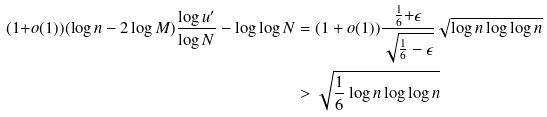Convert formula to latex. <formula><loc_0><loc_0><loc_500><loc_500>( 1 { + } o ( 1 ) ) ( \log n - 2 \log M ) \frac { \log u ^ { \prime } } { \log N } - \log \log N & = ( 1 + o ( 1 ) ) \frac { \frac { 1 } { 6 } { + } \epsilon } { \sqrt { \frac { 1 } { 6 } - \epsilon } } \sqrt { \log n \log \log n } \\ & > \sqrt { \frac { 1 } { 6 } \log n \log \log n }</formula> 